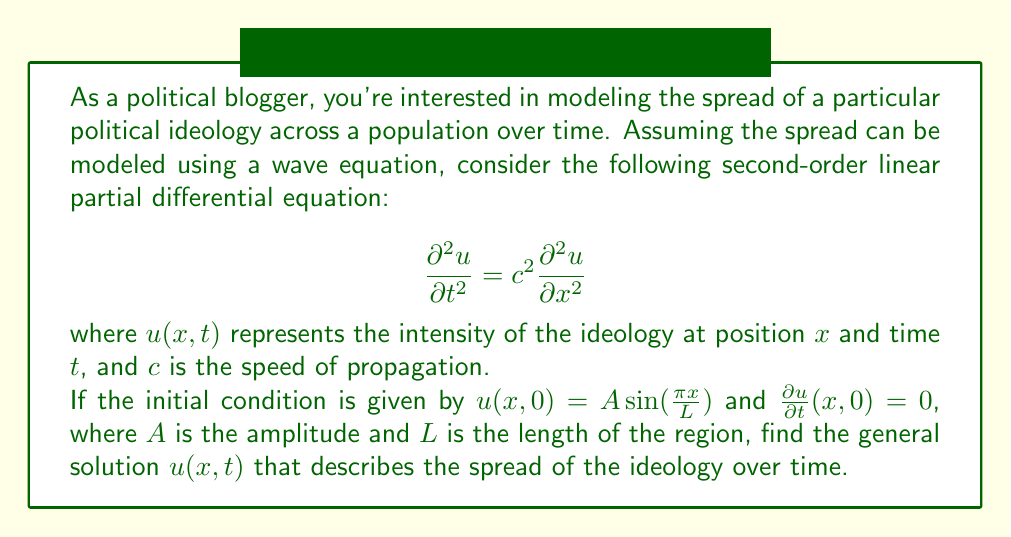Can you answer this question? To solve this problem, we'll follow these steps:

1) The general solution for a wave equation of this form is given by:

   $$u(x,t) = f(x-ct) + g(x+ct)$$

   where $f$ and $g$ are arbitrary functions.

2) Given the initial conditions, we can use the method of separation of variables. Let's assume a solution of the form:

   $$u(x,t) = X(x)T(t)$$

3) Substituting this into the wave equation:

   $$X(x)T''(t) = c^2X''(x)T(t)$$

4) Dividing both sides by $c^2X(x)T(t)$:

   $$\frac{T''(t)}{c^2T(t)} = \frac{X''(x)}{X(x)} = -k^2$$

   where $-k^2$ is a separation constant.

5) This gives us two ordinary differential equations:

   $$X''(x) + k^2X(x) = 0$$
   $$T''(t) + c^2k^2T(t) = 0$$

6) The general solutions to these equations are:

   $$X(x) = A\sin(kx) + B\cos(kx)$$
   $$T(t) = C\sin(ckt) + D\cos(ckt)$$

7) From the initial condition $u(x,0) = A \sin(\frac{\pi x}{L})$, we can deduce:

   $$k = \frac{\pi}{L}$$

8) The general solution is therefore:

   $$u(x,t) = (A\sin(\frac{\pi x}{L}) + B\cos(\frac{\pi x}{L}))(C\sin(\frac{c\pi t}{L}) + D\cos(\frac{c\pi t}{L}))$$

9) Applying the initial conditions:

   $u(x,0) = A \sin(\frac{\pi x}{L})$ implies $B = 0$ and $D = 1$
   $\frac{\partial u}{\partial t}(x,0) = 0$ implies $C = 0$

10) Therefore, the final solution is:

    $$u(x,t) = A \sin(\frac{\pi x}{L}) \cos(\frac{c\pi t}{L})$$

This solution represents a standing wave, which in the context of political ideology spread, suggests that the intensity of the ideology oscillates in place over time, rather than propagating across the region.
Answer: $$u(x,t) = A \sin(\frac{\pi x}{L}) \cos(\frac{c\pi t}{L})$$ 